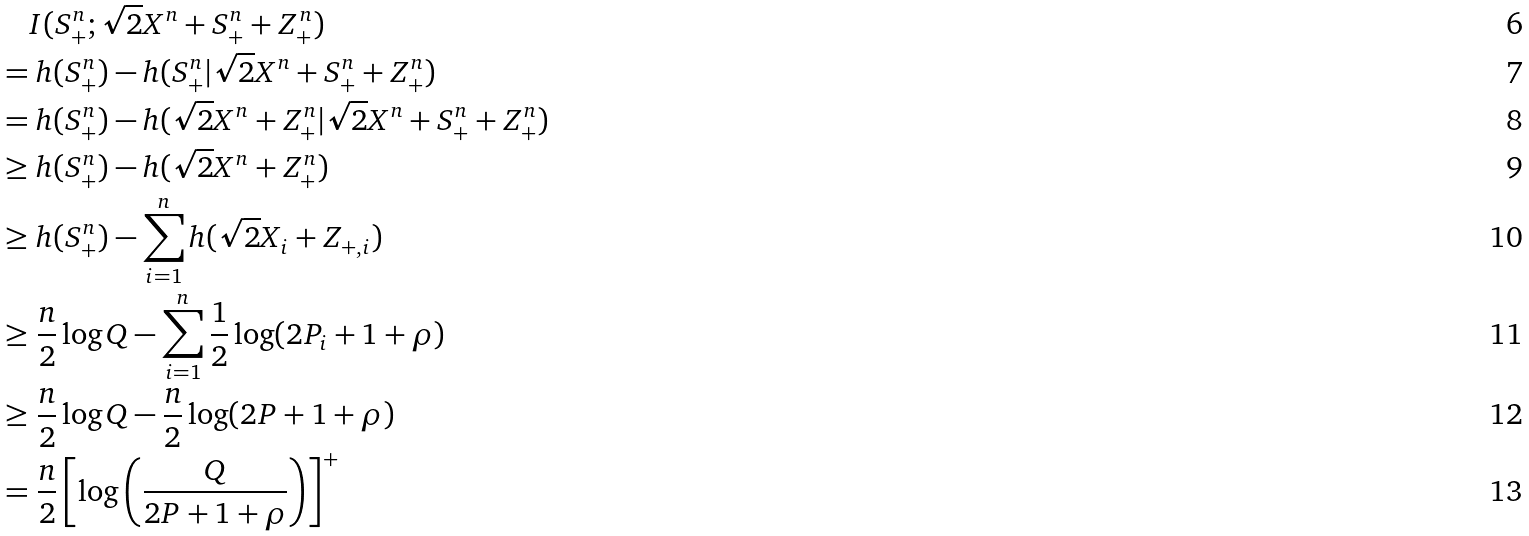Convert formula to latex. <formula><loc_0><loc_0><loc_500><loc_500>& \quad I ( S _ { + } ^ { n } ; \sqrt { 2 } X ^ { n } + S _ { + } ^ { n } + Z _ { + } ^ { n } ) \\ & = h ( S _ { + } ^ { n } ) - h ( S _ { + } ^ { n } | \sqrt { 2 } X ^ { n } + S _ { + } ^ { n } + Z _ { + } ^ { n } ) \\ & = h ( S _ { + } ^ { n } ) - h ( \sqrt { 2 } X ^ { n } + Z _ { + } ^ { n } | \sqrt { 2 } X ^ { n } + S _ { + } ^ { n } + Z _ { + } ^ { n } ) \\ & \geq h ( S _ { + } ^ { n } ) - h ( \sqrt { 2 } X ^ { n } + Z _ { + } ^ { n } ) \\ & \geq h ( S _ { + } ^ { n } ) - \sum _ { i = 1 } ^ { n } h ( \sqrt { 2 } X _ { i } + Z _ { + , i } ) \\ & \geq \frac { n } { 2 } \log Q - \sum _ { i = 1 } ^ { n } \frac { 1 } { 2 } \log ( 2 P _ { i } + 1 + \rho ) \\ & \geq \frac { n } { 2 } \log Q - \frac { n } { 2 } \log ( 2 P + 1 + \rho ) \\ & = \frac { n } { 2 } \left [ \log \left ( \frac { Q } { 2 P + 1 + \rho } \right ) \right ] ^ { + }</formula> 